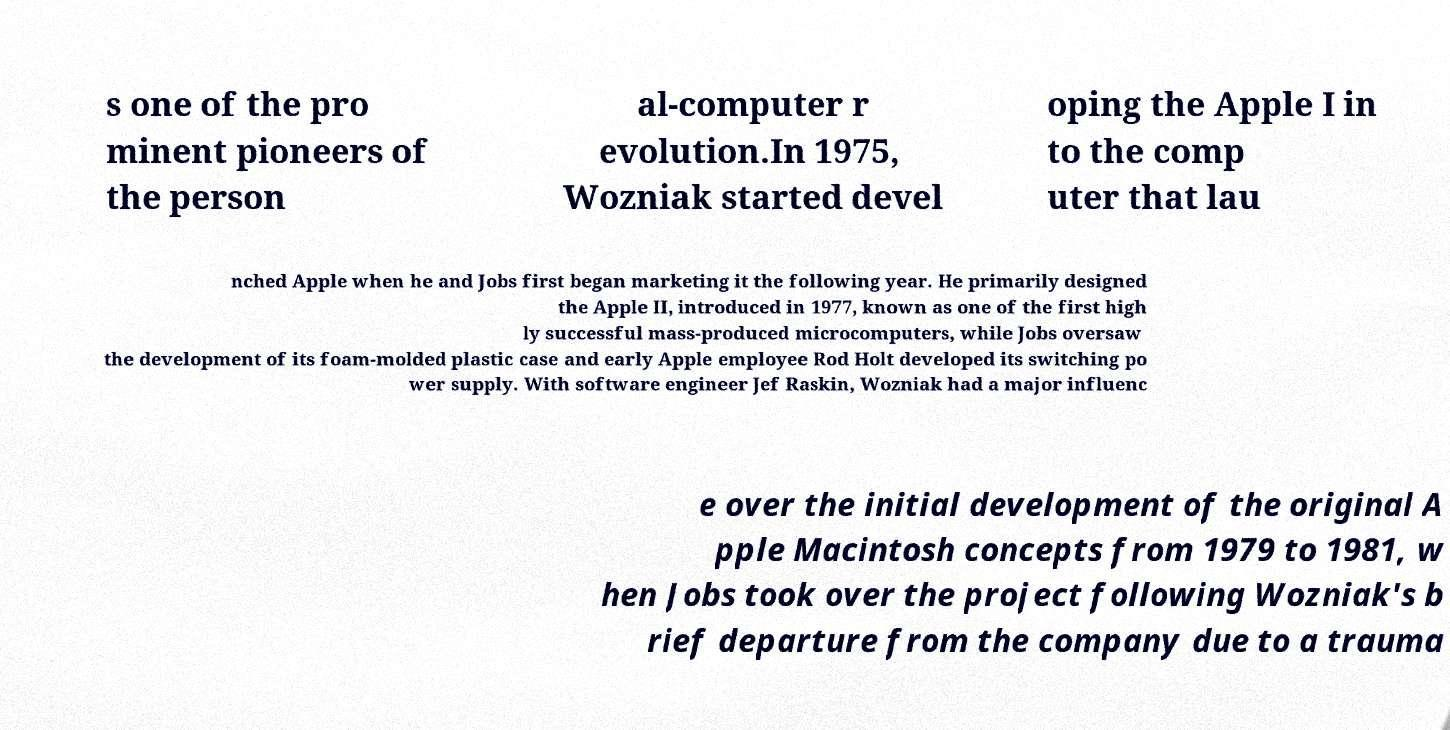I need the written content from this picture converted into text. Can you do that? s one of the pro minent pioneers of the person al-computer r evolution.In 1975, Wozniak started devel oping the Apple I in to the comp uter that lau nched Apple when he and Jobs first began marketing it the following year. He primarily designed the Apple II, introduced in 1977, known as one of the first high ly successful mass-produced microcomputers, while Jobs oversaw the development of its foam-molded plastic case and early Apple employee Rod Holt developed its switching po wer supply. With software engineer Jef Raskin, Wozniak had a major influenc e over the initial development of the original A pple Macintosh concepts from 1979 to 1981, w hen Jobs took over the project following Wozniak's b rief departure from the company due to a trauma 